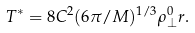<formula> <loc_0><loc_0><loc_500><loc_500>T ^ { * } = 8 C ^ { 2 } ( 6 \pi / M ) ^ { 1 / 3 } \rho _ { \perp } ^ { 0 } r .</formula> 